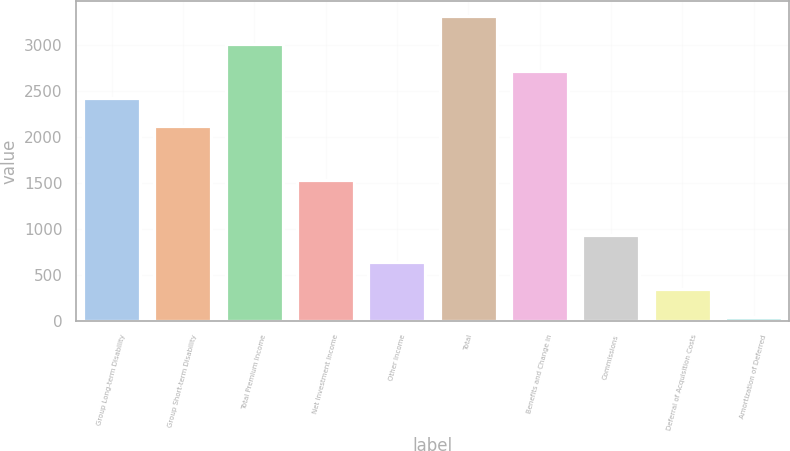<chart> <loc_0><loc_0><loc_500><loc_500><bar_chart><fcel>Group Long-term Disability<fcel>Group Short-term Disability<fcel>Total Premium Income<fcel>Net Investment Income<fcel>Other Income<fcel>Total<fcel>Benefits and Change in<fcel>Commissions<fcel>Deferral of Acquisition Costs<fcel>Amortization of Deferred<nl><fcel>2420.3<fcel>2123.35<fcel>3014.2<fcel>1529.45<fcel>638.6<fcel>3311.15<fcel>2717.25<fcel>935.55<fcel>341.65<fcel>44.7<nl></chart> 